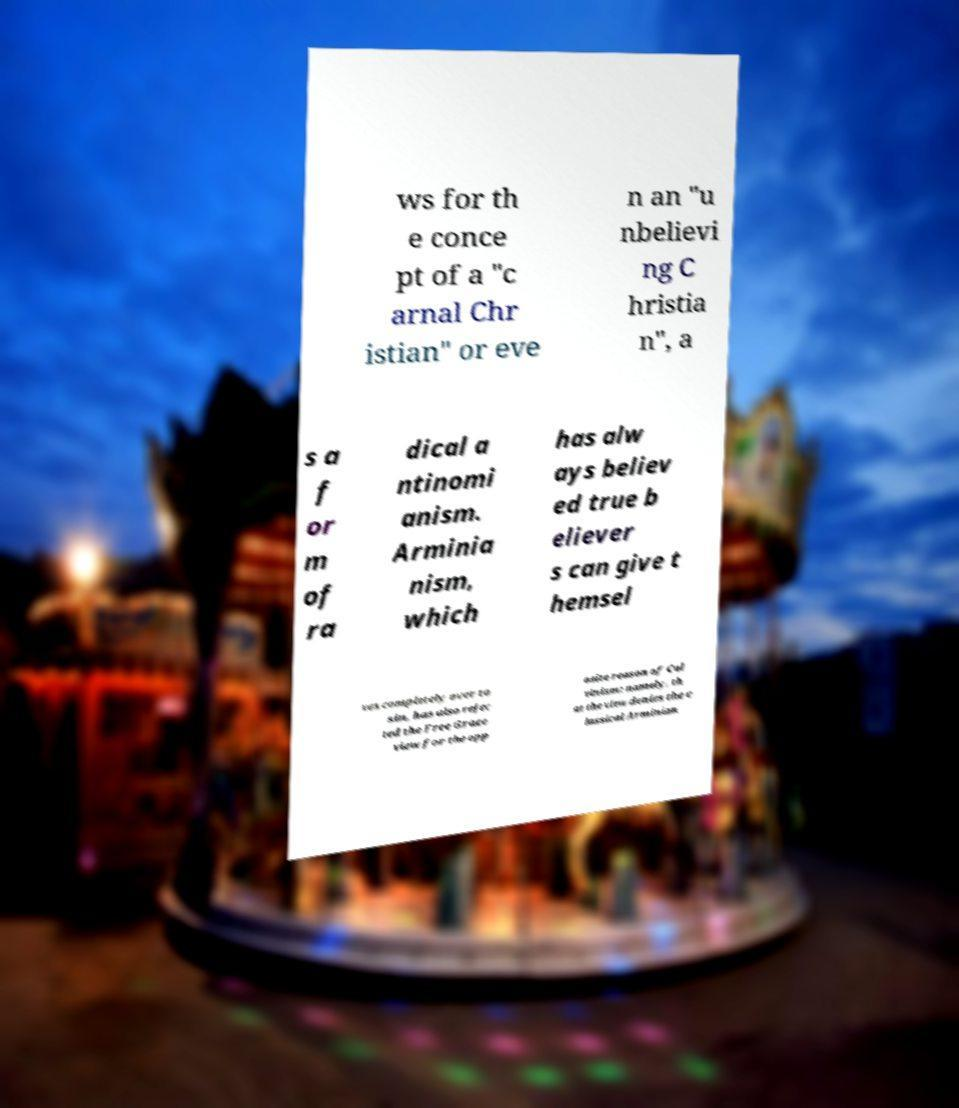Could you assist in decoding the text presented in this image and type it out clearly? ws for th e conce pt of a "c arnal Chr istian" or eve n an "u nbelievi ng C hristia n", a s a f or m of ra dical a ntinomi anism. Arminia nism, which has alw ays believ ed true b eliever s can give t hemsel ves completely over to sin, has also rejec ted the Free Grace view for the opp osite reason of Cal vinism: namely, th at the view denies the c lassical Arminian 